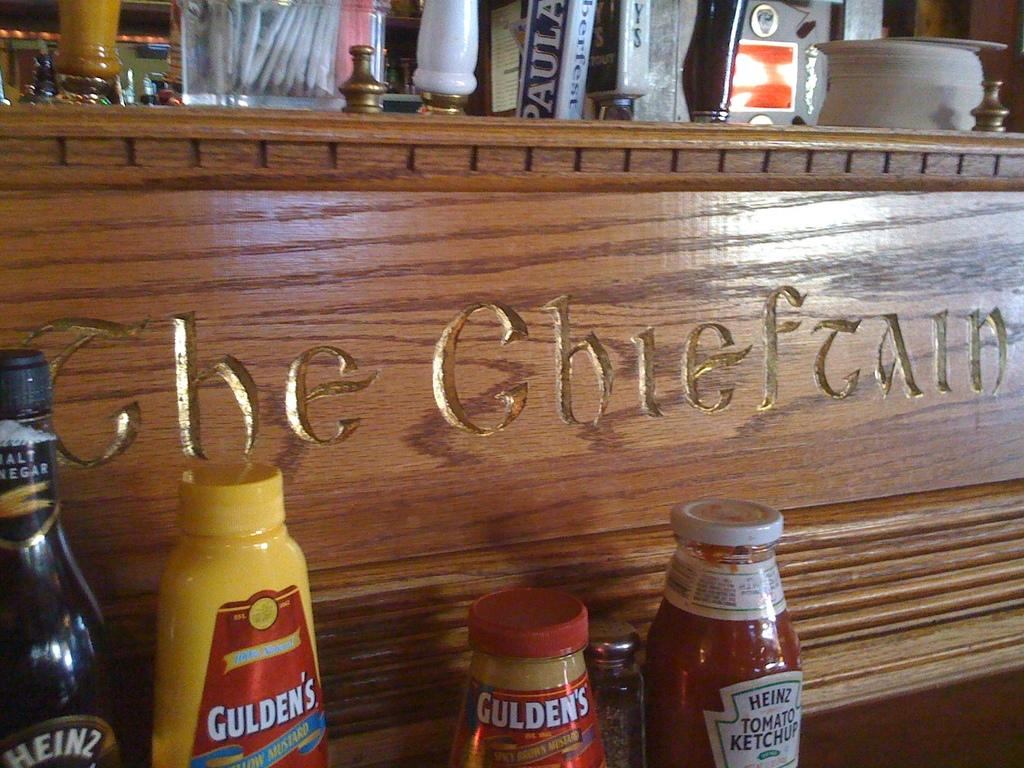<image>
Render a clear and concise summary of the photo. the word gulden's that is on a yellow item 